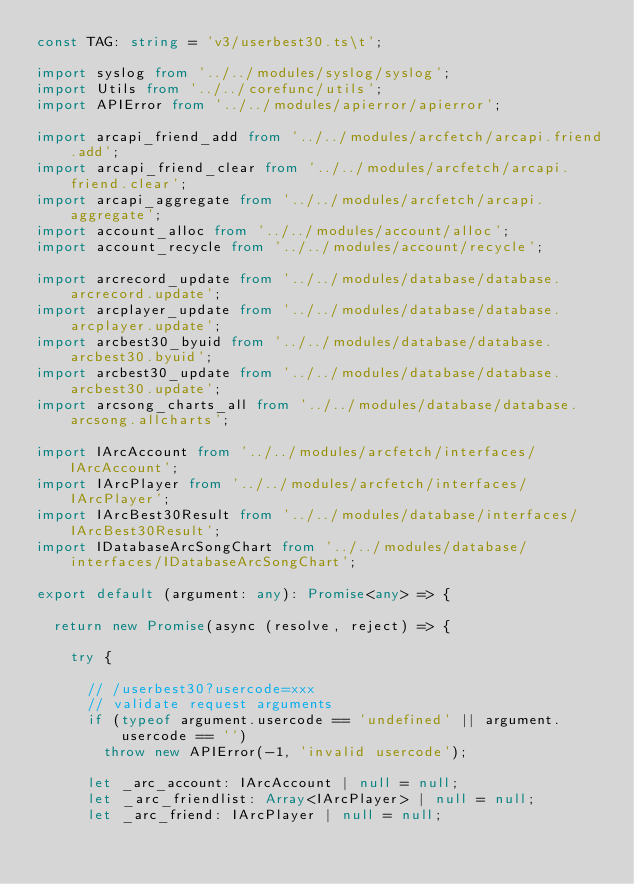Convert code to text. <code><loc_0><loc_0><loc_500><loc_500><_TypeScript_>const TAG: string = 'v3/userbest30.ts\t';

import syslog from '../../modules/syslog/syslog';
import Utils from '../../corefunc/utils';
import APIError from '../../modules/apierror/apierror';

import arcapi_friend_add from '../../modules/arcfetch/arcapi.friend.add';
import arcapi_friend_clear from '../../modules/arcfetch/arcapi.friend.clear';
import arcapi_aggregate from '../../modules/arcfetch/arcapi.aggregate';
import account_alloc from '../../modules/account/alloc';
import account_recycle from '../../modules/account/recycle';

import arcrecord_update from '../../modules/database/database.arcrecord.update';
import arcplayer_update from '../../modules/database/database.arcplayer.update';
import arcbest30_byuid from '../../modules/database/database.arcbest30.byuid';
import arcbest30_update from '../../modules/database/database.arcbest30.update';
import arcsong_charts_all from '../../modules/database/database.arcsong.allcharts';

import IArcAccount from '../../modules/arcfetch/interfaces/IArcAccount';
import IArcPlayer from '../../modules/arcfetch/interfaces/IArcPlayer';
import IArcBest30Result from '../../modules/database/interfaces/IArcBest30Result';
import IDatabaseArcSongChart from '../../modules/database/interfaces/IDatabaseArcSongChart';

export default (argument: any): Promise<any> => {

  return new Promise(async (resolve, reject) => {

    try {

      // /userbest30?usercode=xxx
      // validate request arguments
      if (typeof argument.usercode == 'undefined' || argument.usercode == '')
        throw new APIError(-1, 'invalid usercode');

      let _arc_account: IArcAccount | null = null;
      let _arc_friendlist: Array<IArcPlayer> | null = null;
      let _arc_friend: IArcPlayer | null = null;</code> 